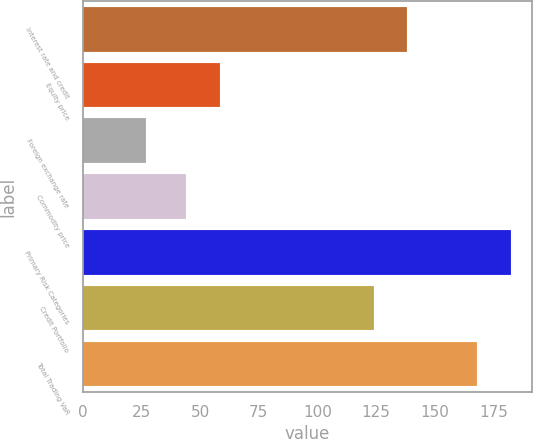<chart> <loc_0><loc_0><loc_500><loc_500><bar_chart><fcel>Interest rate and credit<fcel>Equity price<fcel>Foreign exchange rate<fcel>Commodity price<fcel>Primary Risk Categories<fcel>Credit Portfolio<fcel>Total Trading VaR<nl><fcel>138.3<fcel>58.3<fcel>27<fcel>44<fcel>182.3<fcel>124<fcel>168<nl></chart> 